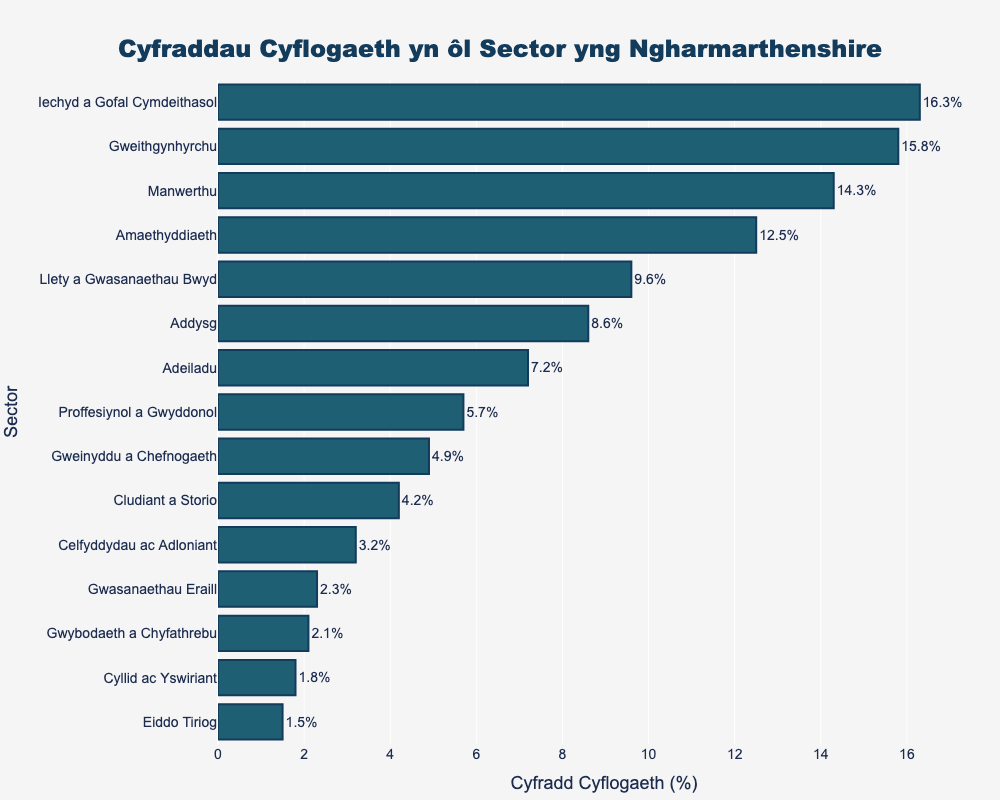Pa sector sydd â'r gyfradd cyflogaeth uchaf? Nwsgrifennu'n ofalus, gallwch weld bod y bar gyda'r hyd mwyaf yw'r sector Iechyd a Gofal Cymdeithasol, sy'n cynrychioli'r gyfradd cyflogaeth uchaf.
Answer: Iechyd a Gofal Cymdeithasol Pa sector sydd â'r gyfradd cyflogaeth isaf? Edrych ar y bar gyda'r hyd lleiaf, gallwch weld mai sector Eiddo Tiriog sydd â'r cyfradd cyflogaeth isaf.
Answer: Eiddo Tiriog Pa mor wahanol yw'r cyfradd cyflogaeth yn y sector Gwybodaeth a Chyfathrebu o'r mewn sector Cyllid ac Yswiriant? Chwiliwch am y bar ar gyfer Gwybodaeth a Chyfathrebu (2.1) a'r bar ar gyfer Cyllid ac Yswiriant (1.8). Gwelwch fod y gwahaniaeth yn 2.1 - 1.8 = 0.3%.
Answer: 0.3% Pa sectorau sydd â chyfradd cyflogaeth uwch na 10%? Edrychwch ar unrhyw far sydd â hyd yn fwy na 10%: Amaethyddiaeth (12.5), Gweithgynhyrchu (15.8), Manwerthu (14.3), a Iechyd a Gofal Cymdeithasol (16.3).
Answer: Amaethyddiaeth, Gweithgynhyrchu, Manwerthu, Iechyd a Gofal Cymdeithasol Beth yw cyfartaledd cyfraddau cyflogaeth y sectorau Gwasanaethau eraill, Addysg, a Gweinyddu a chefnogaeth? Casglwch y cyfraddau cyflogaeth ar gyfer y sectorau hyn: Gwasanaethau eraill (2.3), Addysg (8.6), Gweinyddu a chefnogaeth (4.9). Yna, cyfrifwch y cyfartaledd = (2.3 + 8.6 + 4.9) / 3 = 15.8 / 3 ≈ 5.27.
Answer: 5.27 Pa mor wahanol yw'r gyfradd cyflogaeth rhwng y sector Addysg a Llety a Gwasanaethau Bwyd? Dodwch y gwerthoedd ar gyfer Addysg (8.6) a Llety a Gwasanaethau Bwyd (9.6). Yna gwna'r gwahaniaeth = 9.6 - 8.6 = 1.0%.
Answer: 1.0% Sawl sector sydd â chyfradd cyflogaeth rhwng 1% a 5%? Edrychwch am farau sy'n cwrdd â'r amod hwnnw: Cludiant a Storio (4.2), Gwybodaeth a Chyfathrebu (2.1), Cyllid ac Yswiriant (1.8), Eiddo Tiriog (1.5), Proffesiynol a gwyddonol (5.7), Gweinyddu a chefnogaeth (4.9), Celfyddydau ac adloniant (3.2), Gwasanaethau eraill (2.3). Nifer y sectorau hynny yw 8.
Answer: 8 